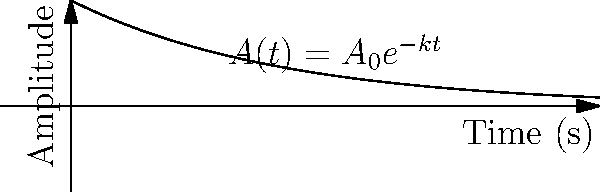In a virtual room for an indie game soundtrack, the amplitude of reverb decay is modeled by the function $A(t) = A_0e^{-kt}$, where $A_0$ is the initial amplitude, $k$ is the decay constant, and $t$ is time in seconds. If the reverb amplitude decreases to 20% of its initial value after 3 seconds, what is the value of the decay constant $k$? Let's approach this step-by-step:

1) We're given that $A(t) = A_0e^{-kt}$

2) After 3 seconds, the amplitude is 20% of the initial value. We can express this as:

   $A(3) = 0.2A_0$

3) Substituting this into our original equation:

   $0.2A_0 = A_0e^{-k(3)}$

4) We can simplify by dividing both sides by $A_0$:

   $0.2 = e^{-3k}$

5) Now, let's take the natural log of both sides:

   $\ln(0.2) = \ln(e^{-3k})$

6) The right side simplifies due to the properties of logarithms:

   $\ln(0.2) = -3k$

7) Now we can solve for $k$:

   $k = -\frac{\ln(0.2)}{3}$

8) Using a calculator or computer, we can evaluate this:

   $k \approx 0.5365$ (rounded to 4 decimal places)
Answer: $k \approx 0.5365$ s$^{-1}$ 